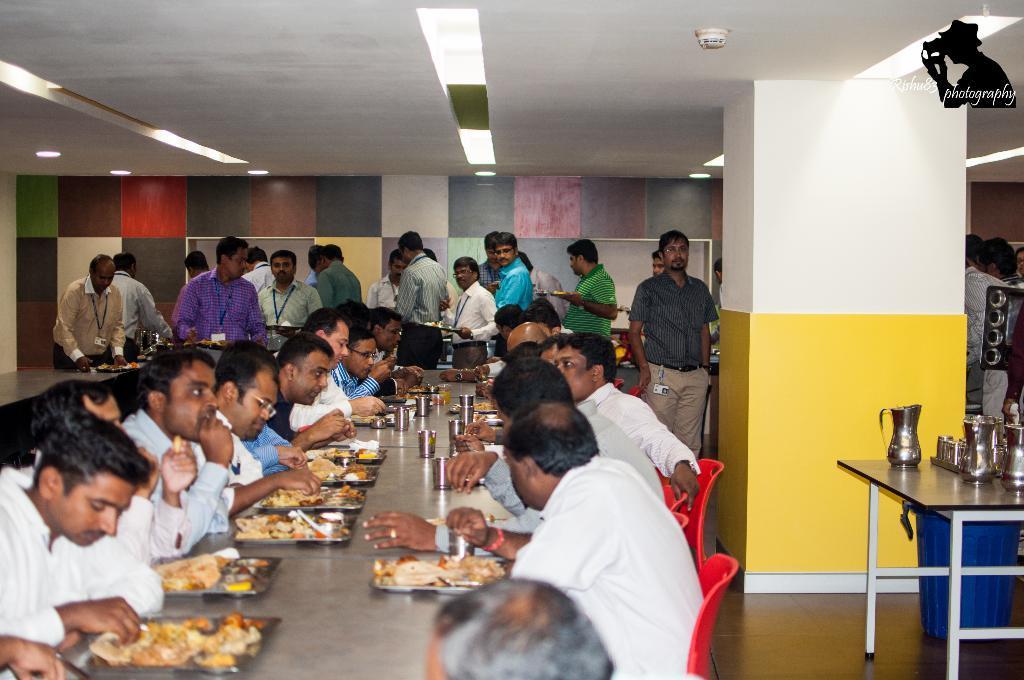In one or two sentences, can you explain what this image depicts? In the picture I can see a group of people. I can see a few people sitting on the chairs eating the food and a few of them are standing on the floor. I can see the tables and chairs on the floor. There is a lighting arrangement on the floor. I can see stainless steel glasses and jars on the table. There is a drum on the floor on the bottom right side. 